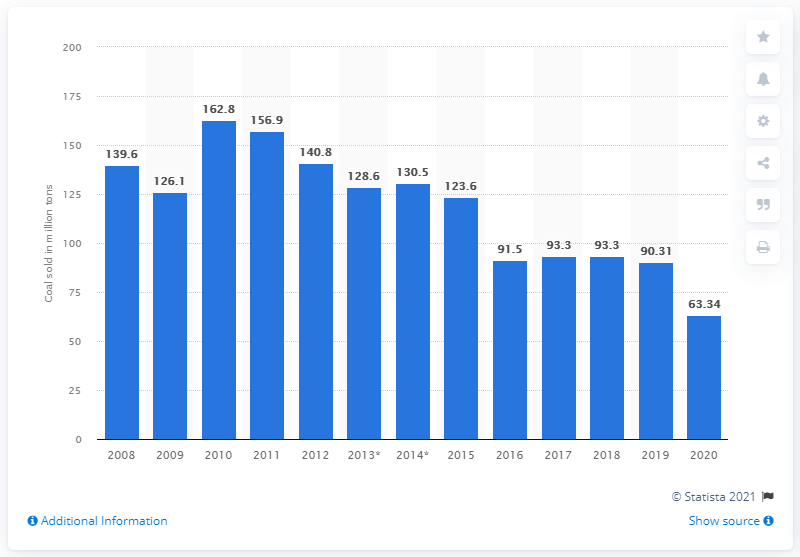Specify some key components in this picture. In 2020, Arch Coal sold 63,340 tons of coal. 